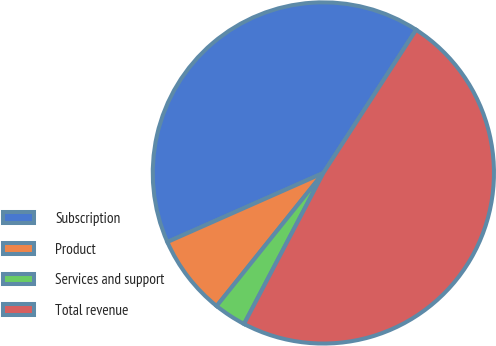Convert chart to OTSL. <chart><loc_0><loc_0><loc_500><loc_500><pie_chart><fcel>Subscription<fcel>Product<fcel>Services and support<fcel>Total revenue<nl><fcel>40.78%<fcel>7.61%<fcel>3.06%<fcel>48.54%<nl></chart> 